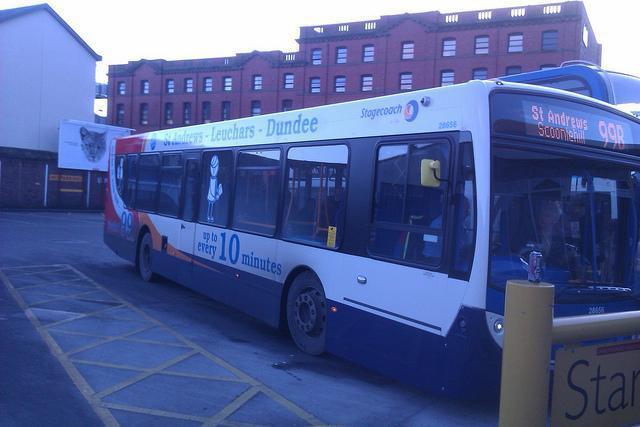How many buses are there?
Give a very brief answer. 2. How many boats are in the water?
Give a very brief answer. 0. 